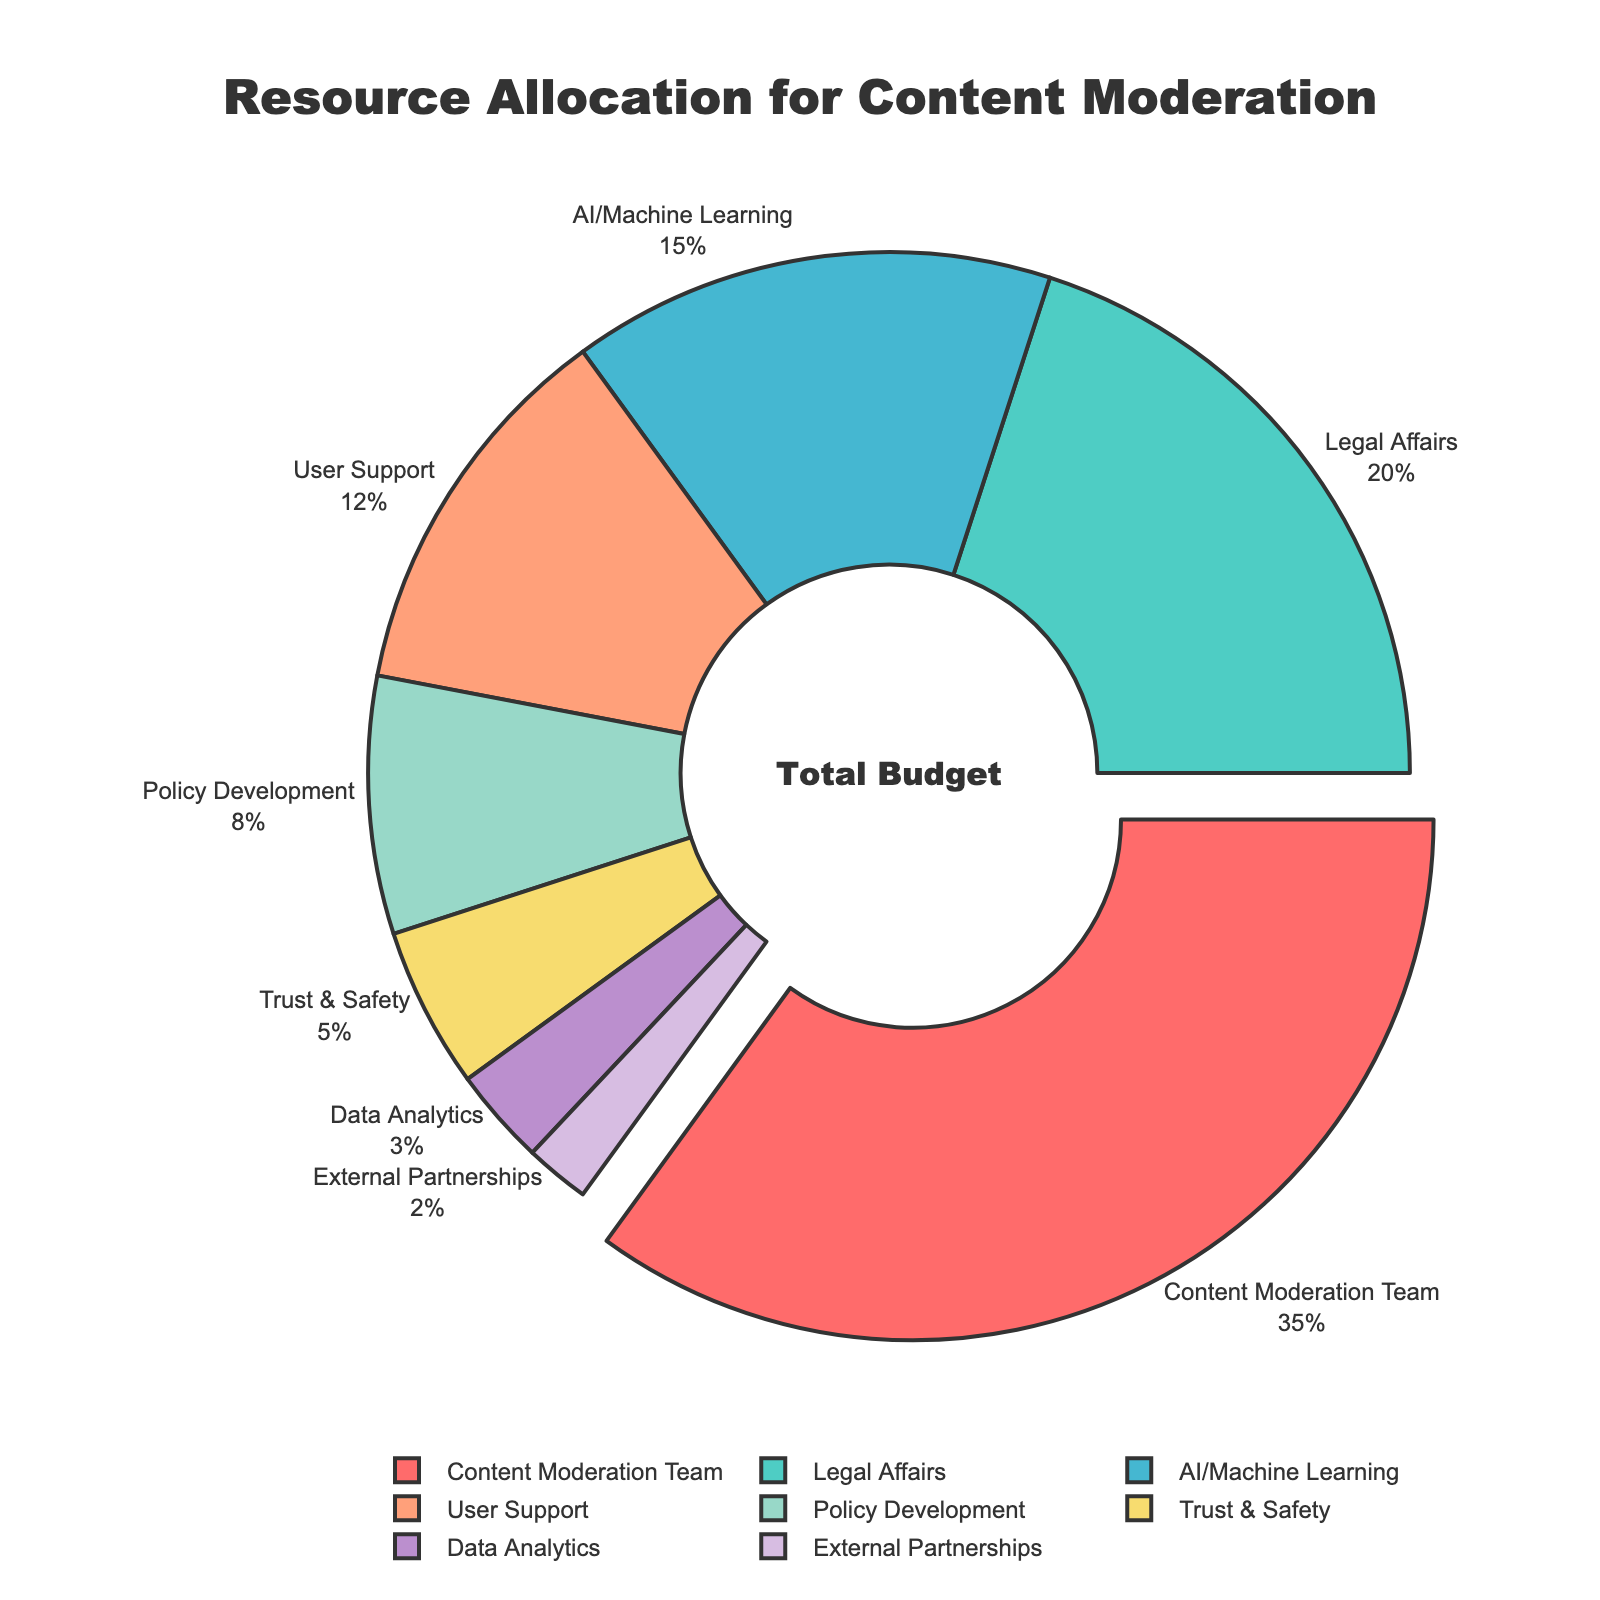Which department has received the highest budget allocation percentage? From the pie chart, we see that the "Content Moderation Team" section is the most prominent and is pulled out from the chart, indicating it receives the highest percentage.
Answer: Content Moderation Team What is the combined budget allocation percentage for AI/Machine Learning and Data Analytics? The AI/Machine Learning department has a 15% allocation, and the Data Analytics department has a 3% allocation. Summing these gives 15% + 3% = 18%.
Answer: 18% Which two departments together receive a lower budget allocation percentage than the Legal Affairs department? The Legal Affairs department has a 20% allocation. The combined allocation for External Partnerships (2%) and Trust & Safety (5%) is 2% + 5% = 7%, which is less than 20%.
Answer: External Partnerships and Trust & Safety How does the budget allocation for User Support compare to Policy Development? User Support has a 12% allocation, whereas Policy Development has an 8% allocation. 12% is greater than 8%.
Answer: User Support has a higher allocation What is the difference in budget allocation percentages between the Content Moderation Team and Trust & Safety? The Content Moderation Team has a 35% allocation, and Trust & Safety has a 5% allocation. The difference is 35% - 5% = 30%.
Answer: 30% How many departments have a budget allocation of less than 10%? By examining the pie chart, departments with less than 10% allocation are Policy Development (8%), Trust & Safety (5%), Data Analytics (3%), and External Partnerships (2%), totaling 4 departments.
Answer: 4 Which department is represented by the green slice of the pie chart? Consulting the figure key or chart legend, the green slice corresponds to the Legal Affairs department.
Answer: Legal Affairs What proportion of the total budget is allocated to departments other than Content Moderation Team? The Content Moderation Team receives 35% allocation. Subtracting this from 100% gives 100% - 35% = 65%.
Answer: 65% If the allocations for AI/Machine Learning and Trust & Safety were combined, what would be the new allocation percentage for this combined category? AI/Machine Learning has a 15% allocation, and Trust & Safety has a 5% allocation. Combined, the percentage is 15% + 5% = 20%.
Answer: 20% Which department has the smallest budget allocation percentage, and what is it? By examining the pie chart, the External Partnerships department has the smallest budget allocation at 2%.
Answer: External Partnerships, 2% 